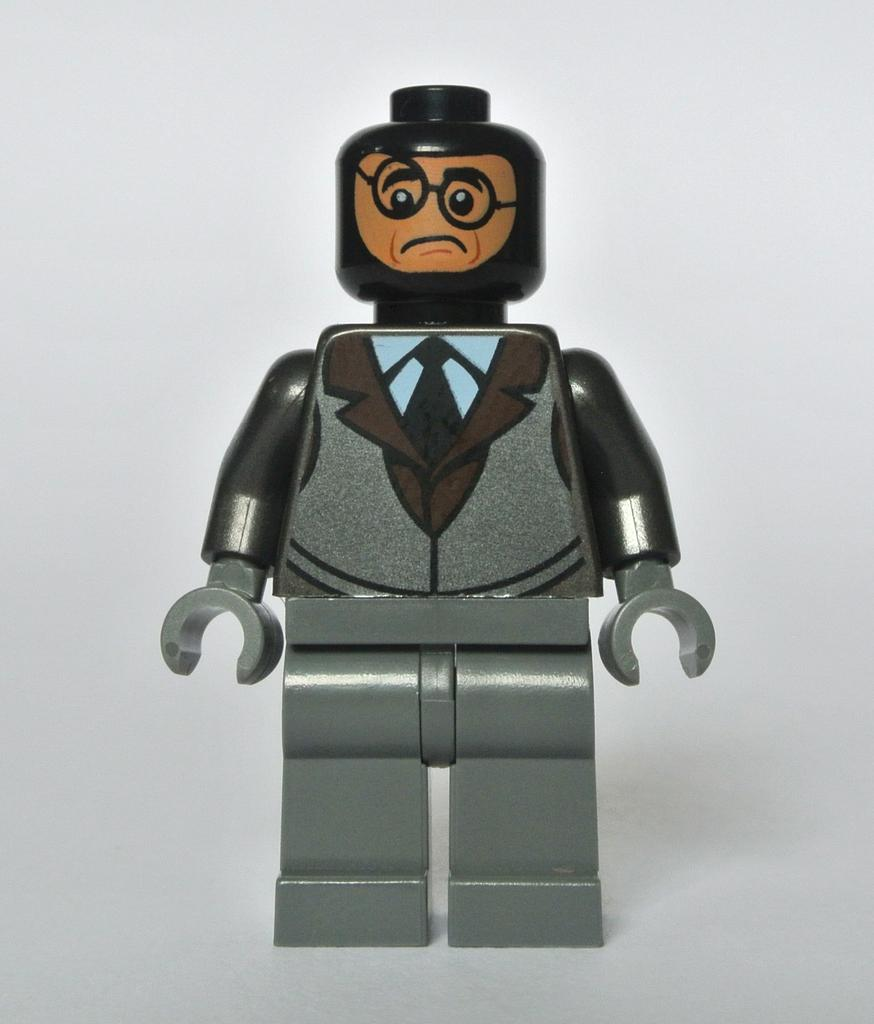What object can be seen in the image? There is a toy in the image. Can you describe the toy's shape? The toy is in the shape of a man. What type of quill is the toy holding in the image? There is no quill present in the image; the toy is in the shape of a man, and no specific objects are mentioned in its hands. 